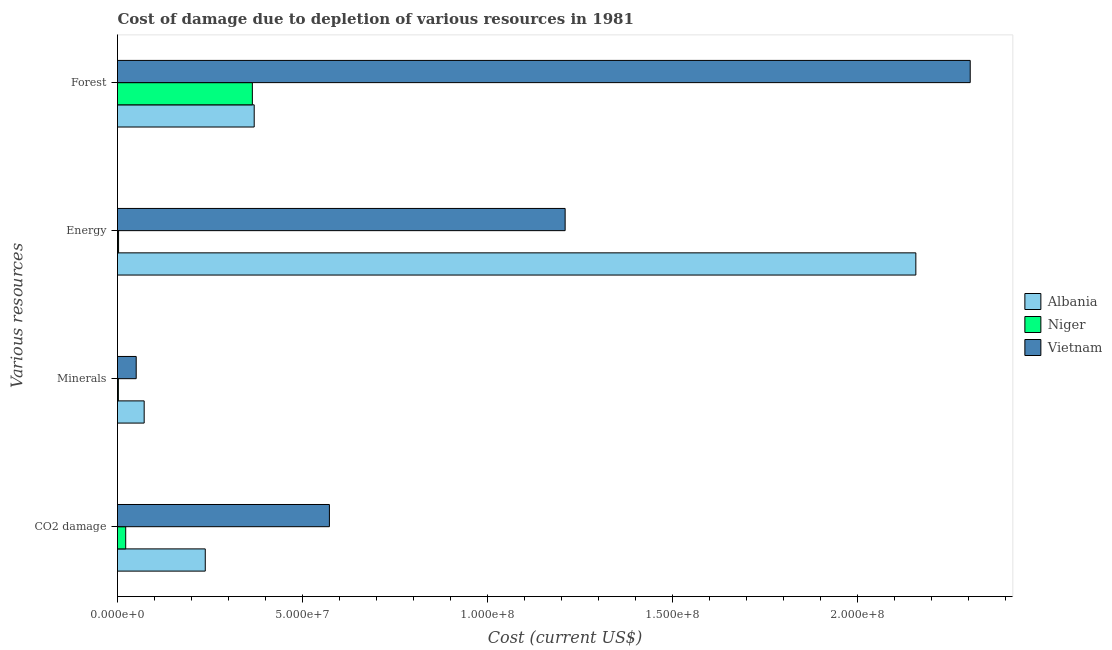How many groups of bars are there?
Provide a succinct answer. 4. What is the label of the 4th group of bars from the top?
Ensure brevity in your answer.  CO2 damage. What is the cost of damage due to depletion of coal in Niger?
Your answer should be very brief. 2.22e+06. Across all countries, what is the maximum cost of damage due to depletion of energy?
Offer a terse response. 2.16e+08. Across all countries, what is the minimum cost of damage due to depletion of energy?
Your response must be concise. 2.86e+05. In which country was the cost of damage due to depletion of energy maximum?
Your answer should be very brief. Albania. In which country was the cost of damage due to depletion of minerals minimum?
Make the answer very short. Niger. What is the total cost of damage due to depletion of coal in the graph?
Your answer should be very brief. 8.32e+07. What is the difference between the cost of damage due to depletion of coal in Vietnam and that in Albania?
Provide a short and direct response. 3.36e+07. What is the difference between the cost of damage due to depletion of minerals in Vietnam and the cost of damage due to depletion of forests in Albania?
Keep it short and to the point. -3.19e+07. What is the average cost of damage due to depletion of forests per country?
Your answer should be compact. 1.01e+08. What is the difference between the cost of damage due to depletion of forests and cost of damage due to depletion of minerals in Albania?
Your answer should be very brief. 2.97e+07. In how many countries, is the cost of damage due to depletion of forests greater than 40000000 US$?
Your answer should be very brief. 1. What is the ratio of the cost of damage due to depletion of energy in Albania to that in Niger?
Provide a succinct answer. 754.65. Is the difference between the cost of damage due to depletion of coal in Vietnam and Albania greater than the difference between the cost of damage due to depletion of minerals in Vietnam and Albania?
Provide a short and direct response. Yes. What is the difference between the highest and the second highest cost of damage due to depletion of minerals?
Give a very brief answer. 2.16e+06. What is the difference between the highest and the lowest cost of damage due to depletion of coal?
Offer a very short reply. 5.51e+07. Is the sum of the cost of damage due to depletion of coal in Niger and Albania greater than the maximum cost of damage due to depletion of forests across all countries?
Give a very brief answer. No. Is it the case that in every country, the sum of the cost of damage due to depletion of energy and cost of damage due to depletion of forests is greater than the sum of cost of damage due to depletion of minerals and cost of damage due to depletion of coal?
Your answer should be compact. Yes. What does the 1st bar from the top in CO2 damage represents?
Your response must be concise. Vietnam. What does the 1st bar from the bottom in Energy represents?
Your answer should be compact. Albania. Is it the case that in every country, the sum of the cost of damage due to depletion of coal and cost of damage due to depletion of minerals is greater than the cost of damage due to depletion of energy?
Your answer should be compact. No. How many bars are there?
Your answer should be very brief. 12. Are all the bars in the graph horizontal?
Give a very brief answer. Yes. What is the difference between two consecutive major ticks on the X-axis?
Provide a short and direct response. 5.00e+07. Does the graph contain grids?
Provide a short and direct response. No. How many legend labels are there?
Provide a short and direct response. 3. How are the legend labels stacked?
Your response must be concise. Vertical. What is the title of the graph?
Offer a terse response. Cost of damage due to depletion of various resources in 1981 . Does "Dominica" appear as one of the legend labels in the graph?
Provide a succinct answer. No. What is the label or title of the X-axis?
Offer a very short reply. Cost (current US$). What is the label or title of the Y-axis?
Your answer should be compact. Various resources. What is the Cost (current US$) of Albania in CO2 damage?
Keep it short and to the point. 2.37e+07. What is the Cost (current US$) in Niger in CO2 damage?
Give a very brief answer. 2.22e+06. What is the Cost (current US$) in Vietnam in CO2 damage?
Provide a short and direct response. 5.73e+07. What is the Cost (current US$) in Albania in Minerals?
Your answer should be compact. 7.21e+06. What is the Cost (current US$) of Niger in Minerals?
Your answer should be compact. 2.35e+05. What is the Cost (current US$) of Vietnam in Minerals?
Your answer should be very brief. 5.06e+06. What is the Cost (current US$) of Albania in Energy?
Provide a short and direct response. 2.16e+08. What is the Cost (current US$) in Niger in Energy?
Give a very brief answer. 2.86e+05. What is the Cost (current US$) in Vietnam in Energy?
Your response must be concise. 1.21e+08. What is the Cost (current US$) in Albania in Forest?
Ensure brevity in your answer.  3.70e+07. What is the Cost (current US$) of Niger in Forest?
Make the answer very short. 3.65e+07. What is the Cost (current US$) in Vietnam in Forest?
Offer a very short reply. 2.31e+08. Across all Various resources, what is the maximum Cost (current US$) in Albania?
Make the answer very short. 2.16e+08. Across all Various resources, what is the maximum Cost (current US$) in Niger?
Offer a very short reply. 3.65e+07. Across all Various resources, what is the maximum Cost (current US$) in Vietnam?
Give a very brief answer. 2.31e+08. Across all Various resources, what is the minimum Cost (current US$) in Albania?
Ensure brevity in your answer.  7.21e+06. Across all Various resources, what is the minimum Cost (current US$) in Niger?
Keep it short and to the point. 2.35e+05. Across all Various resources, what is the minimum Cost (current US$) in Vietnam?
Offer a very short reply. 5.06e+06. What is the total Cost (current US$) in Albania in the graph?
Ensure brevity in your answer.  2.84e+08. What is the total Cost (current US$) of Niger in the graph?
Make the answer very short. 3.92e+07. What is the total Cost (current US$) in Vietnam in the graph?
Make the answer very short. 4.14e+08. What is the difference between the Cost (current US$) of Albania in CO2 damage and that in Minerals?
Give a very brief answer. 1.65e+07. What is the difference between the Cost (current US$) of Niger in CO2 damage and that in Minerals?
Make the answer very short. 1.98e+06. What is the difference between the Cost (current US$) of Vietnam in CO2 damage and that in Minerals?
Offer a very short reply. 5.22e+07. What is the difference between the Cost (current US$) in Albania in CO2 damage and that in Energy?
Give a very brief answer. -1.92e+08. What is the difference between the Cost (current US$) in Niger in CO2 damage and that in Energy?
Give a very brief answer. 1.93e+06. What is the difference between the Cost (current US$) in Vietnam in CO2 damage and that in Energy?
Your answer should be compact. -6.37e+07. What is the difference between the Cost (current US$) of Albania in CO2 damage and that in Forest?
Offer a very short reply. -1.32e+07. What is the difference between the Cost (current US$) of Niger in CO2 damage and that in Forest?
Provide a succinct answer. -3.42e+07. What is the difference between the Cost (current US$) in Vietnam in CO2 damage and that in Forest?
Make the answer very short. -1.73e+08. What is the difference between the Cost (current US$) in Albania in Minerals and that in Energy?
Your answer should be compact. -2.09e+08. What is the difference between the Cost (current US$) of Niger in Minerals and that in Energy?
Your answer should be compact. -5.15e+04. What is the difference between the Cost (current US$) of Vietnam in Minerals and that in Energy?
Ensure brevity in your answer.  -1.16e+08. What is the difference between the Cost (current US$) in Albania in Minerals and that in Forest?
Keep it short and to the point. -2.97e+07. What is the difference between the Cost (current US$) in Niger in Minerals and that in Forest?
Ensure brevity in your answer.  -3.62e+07. What is the difference between the Cost (current US$) of Vietnam in Minerals and that in Forest?
Keep it short and to the point. -2.26e+08. What is the difference between the Cost (current US$) of Albania in Energy and that in Forest?
Your answer should be compact. 1.79e+08. What is the difference between the Cost (current US$) of Niger in Energy and that in Forest?
Your answer should be compact. -3.62e+07. What is the difference between the Cost (current US$) of Vietnam in Energy and that in Forest?
Your answer should be compact. -1.10e+08. What is the difference between the Cost (current US$) in Albania in CO2 damage and the Cost (current US$) in Niger in Minerals?
Keep it short and to the point. 2.35e+07. What is the difference between the Cost (current US$) in Albania in CO2 damage and the Cost (current US$) in Vietnam in Minerals?
Keep it short and to the point. 1.87e+07. What is the difference between the Cost (current US$) in Niger in CO2 damage and the Cost (current US$) in Vietnam in Minerals?
Keep it short and to the point. -2.84e+06. What is the difference between the Cost (current US$) in Albania in CO2 damage and the Cost (current US$) in Niger in Energy?
Offer a terse response. 2.34e+07. What is the difference between the Cost (current US$) of Albania in CO2 damage and the Cost (current US$) of Vietnam in Energy?
Offer a terse response. -9.73e+07. What is the difference between the Cost (current US$) in Niger in CO2 damage and the Cost (current US$) in Vietnam in Energy?
Ensure brevity in your answer.  -1.19e+08. What is the difference between the Cost (current US$) in Albania in CO2 damage and the Cost (current US$) in Niger in Forest?
Provide a succinct answer. -1.27e+07. What is the difference between the Cost (current US$) in Albania in CO2 damage and the Cost (current US$) in Vietnam in Forest?
Keep it short and to the point. -2.07e+08. What is the difference between the Cost (current US$) of Niger in CO2 damage and the Cost (current US$) of Vietnam in Forest?
Provide a succinct answer. -2.28e+08. What is the difference between the Cost (current US$) in Albania in Minerals and the Cost (current US$) in Niger in Energy?
Keep it short and to the point. 6.93e+06. What is the difference between the Cost (current US$) in Albania in Minerals and the Cost (current US$) in Vietnam in Energy?
Your response must be concise. -1.14e+08. What is the difference between the Cost (current US$) of Niger in Minerals and the Cost (current US$) of Vietnam in Energy?
Your answer should be very brief. -1.21e+08. What is the difference between the Cost (current US$) of Albania in Minerals and the Cost (current US$) of Niger in Forest?
Provide a short and direct response. -2.93e+07. What is the difference between the Cost (current US$) of Albania in Minerals and the Cost (current US$) of Vietnam in Forest?
Your answer should be very brief. -2.23e+08. What is the difference between the Cost (current US$) in Niger in Minerals and the Cost (current US$) in Vietnam in Forest?
Provide a succinct answer. -2.30e+08. What is the difference between the Cost (current US$) in Albania in Energy and the Cost (current US$) in Niger in Forest?
Ensure brevity in your answer.  1.79e+08. What is the difference between the Cost (current US$) of Albania in Energy and the Cost (current US$) of Vietnam in Forest?
Provide a succinct answer. -1.47e+07. What is the difference between the Cost (current US$) of Niger in Energy and the Cost (current US$) of Vietnam in Forest?
Offer a very short reply. -2.30e+08. What is the average Cost (current US$) of Albania per Various resources?
Ensure brevity in your answer.  7.09e+07. What is the average Cost (current US$) of Niger per Various resources?
Your answer should be very brief. 9.80e+06. What is the average Cost (current US$) of Vietnam per Various resources?
Make the answer very short. 1.03e+08. What is the difference between the Cost (current US$) of Albania and Cost (current US$) of Niger in CO2 damage?
Give a very brief answer. 2.15e+07. What is the difference between the Cost (current US$) of Albania and Cost (current US$) of Vietnam in CO2 damage?
Your response must be concise. -3.36e+07. What is the difference between the Cost (current US$) of Niger and Cost (current US$) of Vietnam in CO2 damage?
Provide a short and direct response. -5.51e+07. What is the difference between the Cost (current US$) in Albania and Cost (current US$) in Niger in Minerals?
Offer a terse response. 6.98e+06. What is the difference between the Cost (current US$) of Albania and Cost (current US$) of Vietnam in Minerals?
Offer a terse response. 2.16e+06. What is the difference between the Cost (current US$) in Niger and Cost (current US$) in Vietnam in Minerals?
Give a very brief answer. -4.82e+06. What is the difference between the Cost (current US$) of Albania and Cost (current US$) of Niger in Energy?
Provide a short and direct response. 2.16e+08. What is the difference between the Cost (current US$) in Albania and Cost (current US$) in Vietnam in Energy?
Your response must be concise. 9.48e+07. What is the difference between the Cost (current US$) of Niger and Cost (current US$) of Vietnam in Energy?
Your answer should be very brief. -1.21e+08. What is the difference between the Cost (current US$) in Albania and Cost (current US$) in Niger in Forest?
Ensure brevity in your answer.  4.99e+05. What is the difference between the Cost (current US$) of Albania and Cost (current US$) of Vietnam in Forest?
Make the answer very short. -1.94e+08. What is the difference between the Cost (current US$) in Niger and Cost (current US$) in Vietnam in Forest?
Provide a short and direct response. -1.94e+08. What is the ratio of the Cost (current US$) in Albania in CO2 damage to that in Minerals?
Your answer should be compact. 3.29. What is the ratio of the Cost (current US$) in Niger in CO2 damage to that in Minerals?
Your answer should be compact. 9.45. What is the ratio of the Cost (current US$) of Vietnam in CO2 damage to that in Minerals?
Make the answer very short. 11.33. What is the ratio of the Cost (current US$) of Albania in CO2 damage to that in Energy?
Give a very brief answer. 0.11. What is the ratio of the Cost (current US$) in Niger in CO2 damage to that in Energy?
Your answer should be very brief. 7.75. What is the ratio of the Cost (current US$) in Vietnam in CO2 damage to that in Energy?
Ensure brevity in your answer.  0.47. What is the ratio of the Cost (current US$) in Albania in CO2 damage to that in Forest?
Make the answer very short. 0.64. What is the ratio of the Cost (current US$) in Niger in CO2 damage to that in Forest?
Your answer should be very brief. 0.06. What is the ratio of the Cost (current US$) in Vietnam in CO2 damage to that in Forest?
Make the answer very short. 0.25. What is the ratio of the Cost (current US$) in Albania in Minerals to that in Energy?
Keep it short and to the point. 0.03. What is the ratio of the Cost (current US$) of Niger in Minerals to that in Energy?
Offer a very short reply. 0.82. What is the ratio of the Cost (current US$) in Vietnam in Minerals to that in Energy?
Keep it short and to the point. 0.04. What is the ratio of the Cost (current US$) of Albania in Minerals to that in Forest?
Give a very brief answer. 0.2. What is the ratio of the Cost (current US$) in Niger in Minerals to that in Forest?
Your response must be concise. 0.01. What is the ratio of the Cost (current US$) in Vietnam in Minerals to that in Forest?
Provide a succinct answer. 0.02. What is the ratio of the Cost (current US$) in Albania in Energy to that in Forest?
Your answer should be compact. 5.84. What is the ratio of the Cost (current US$) of Niger in Energy to that in Forest?
Ensure brevity in your answer.  0.01. What is the ratio of the Cost (current US$) of Vietnam in Energy to that in Forest?
Offer a very short reply. 0.53. What is the difference between the highest and the second highest Cost (current US$) of Albania?
Your answer should be very brief. 1.79e+08. What is the difference between the highest and the second highest Cost (current US$) in Niger?
Give a very brief answer. 3.42e+07. What is the difference between the highest and the second highest Cost (current US$) in Vietnam?
Give a very brief answer. 1.10e+08. What is the difference between the highest and the lowest Cost (current US$) of Albania?
Offer a very short reply. 2.09e+08. What is the difference between the highest and the lowest Cost (current US$) in Niger?
Keep it short and to the point. 3.62e+07. What is the difference between the highest and the lowest Cost (current US$) in Vietnam?
Offer a very short reply. 2.26e+08. 